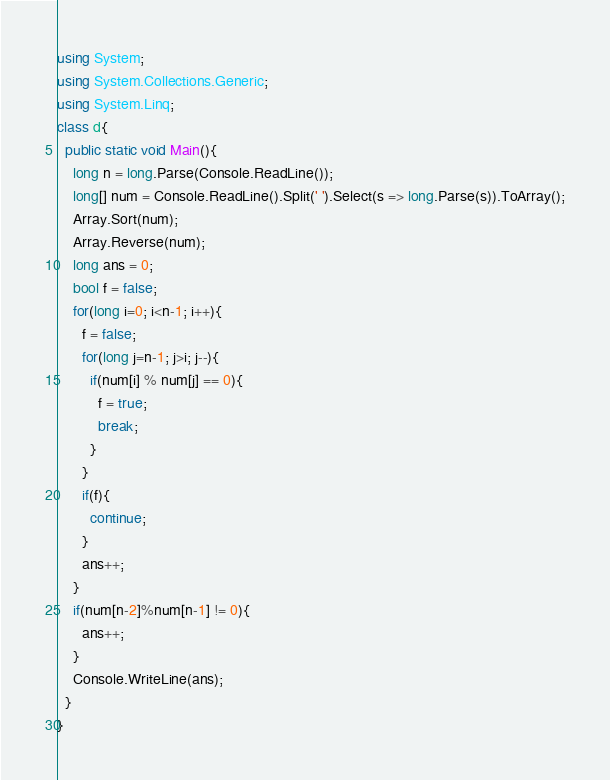<code> <loc_0><loc_0><loc_500><loc_500><_C#_>using System;
using System.Collections.Generic;
using System.Linq;
class d{
  public static void Main(){
    long n = long.Parse(Console.ReadLine());
    long[] num = Console.ReadLine().Split(' ').Select(s => long.Parse(s)).ToArray();
    Array.Sort(num);
    Array.Reverse(num);
    long ans = 0;
    bool f = false;
    for(long i=0; i<n-1; i++){
      f = false;
      for(long j=n-1; j>i; j--){
        if(num[i] % num[j] == 0){
          f = true;
          break;
        }
      }
      if(f){
        continue;
      }
      ans++;
    }
    if(num[n-2]%num[n-1] != 0){
      ans++;
    }
    Console.WriteLine(ans);
  }
}
</code> 